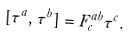<formula> <loc_0><loc_0><loc_500><loc_500>[ \tau ^ { a } , \tau ^ { b } ] = F _ { c } ^ { a b } \tau ^ { c } .</formula> 